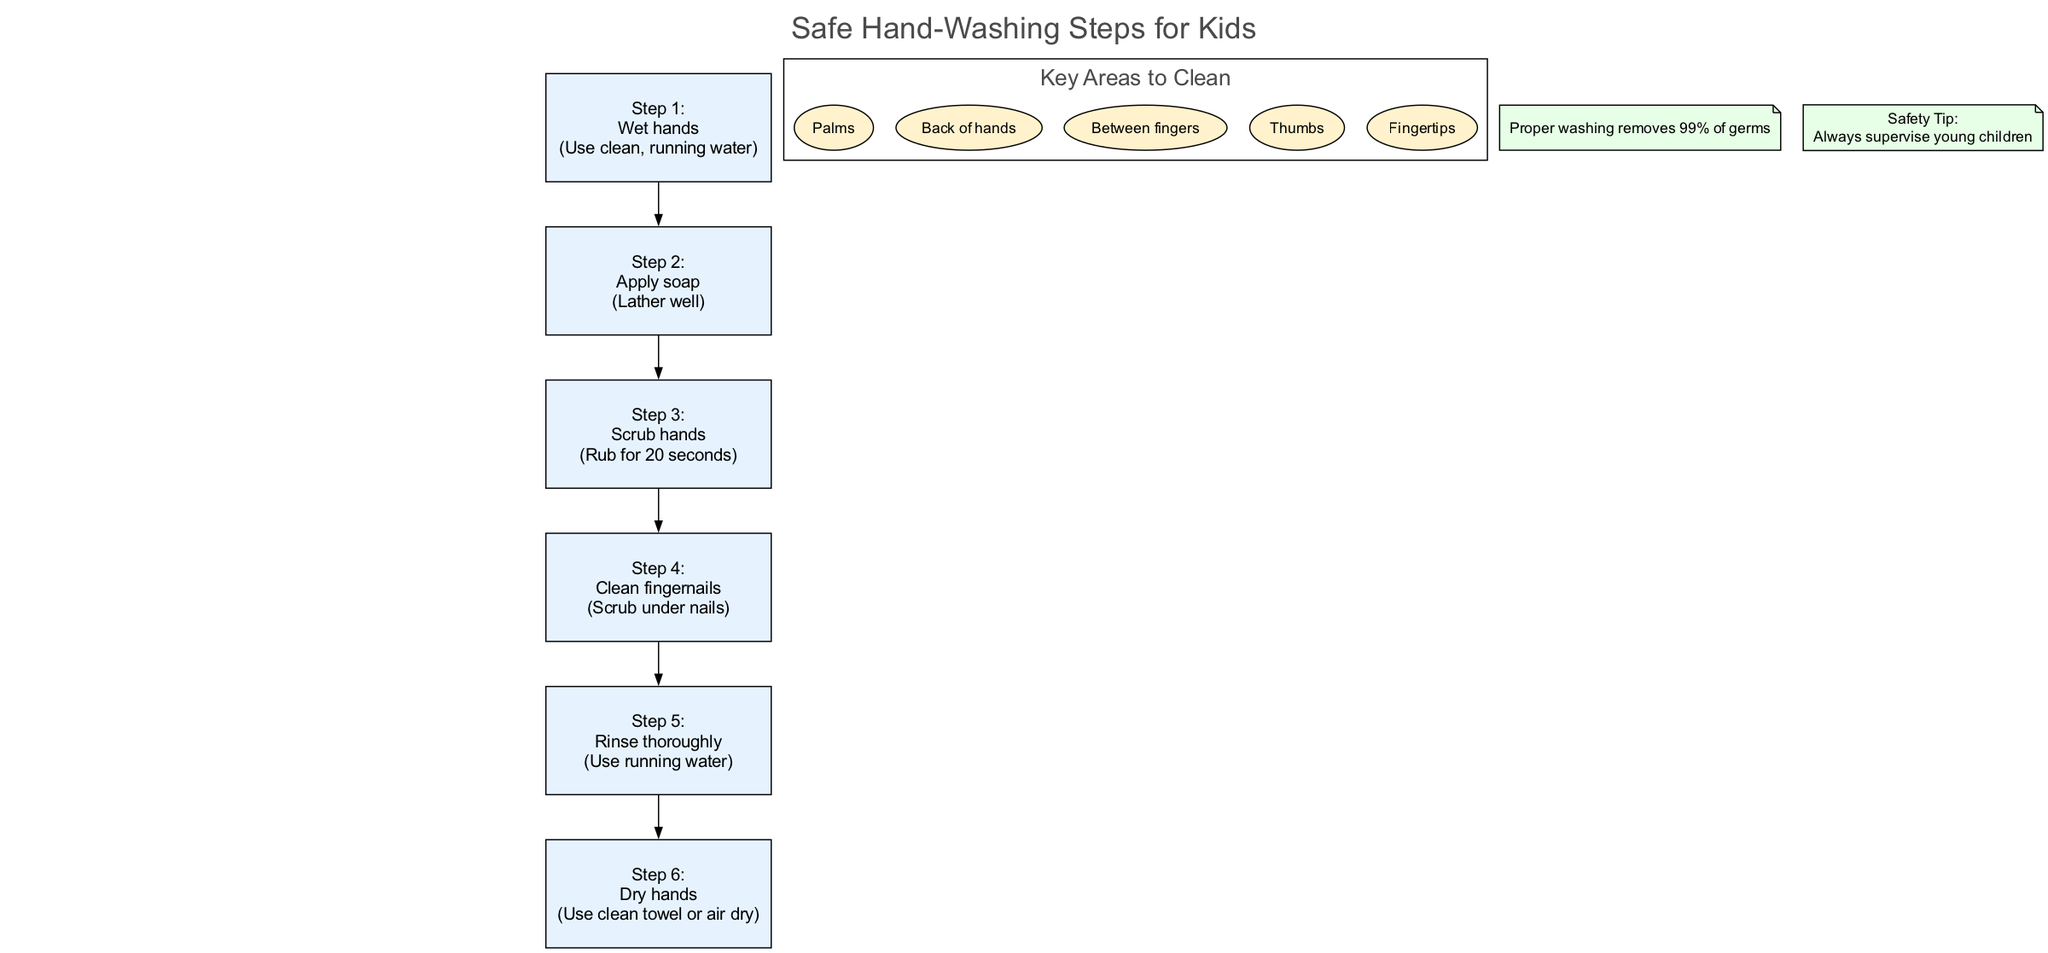What is the first action in the hand-washing steps? The first action listed in the steps of the diagram is "Wet hands". This is explicitly stated in Step 1 of the hand-washing techniques.
Answer: Wet hands How many key areas should children focus on while washing their hands? The diagram specifies that there are five key areas identified that children should focus on during the hand-washing process.
Answer: Five What is the duration for scrubbing hands according to the steps? Step 3 of the diagram indicates that scrubbing hands should last for 20 seconds. This detail is a part of the explicit instructions provided in that step.
Answer: 20 seconds What do you need to rinse off after applying soap? The rinsing action corresponds to Step 5, where it specifies to "Rinse thoroughly" after applying soap. This indicates that the soap needs to be rinsed off using running water.
Answer: Soap What is the final step in the hand-washing process? The last action indicated in the hand-washing steps is to "Dry hands," which is Step 6 of the diagram. This is the concluding action after all previous steps have been followed.
Answer: Dry hands Why is supervision recommended for young children during hand-washing? The diagram states a safety tip that emphasizes the need for supervision because young children may not follow the hand-washing steps correctly without guidance. This highlights the importance of adult oversight for safety.
Answer: Safety Tip: Always supervise young children What does proper washing remove according to the germ removal note? The germ removal note mentioned in the diagram emphasizes that proper washing removes 99% of germs, providing a clear percentage related to the effectiveness of hand-washing.
Answer: 99% of germs Which areas are highlighted for scrubbing under the nails? The diagram includes cleaning fingernails as part of Step 4, specifically stating to "Scrub under nails," indicating the importance of that particular area in germ removal.
Answer: Under nails 